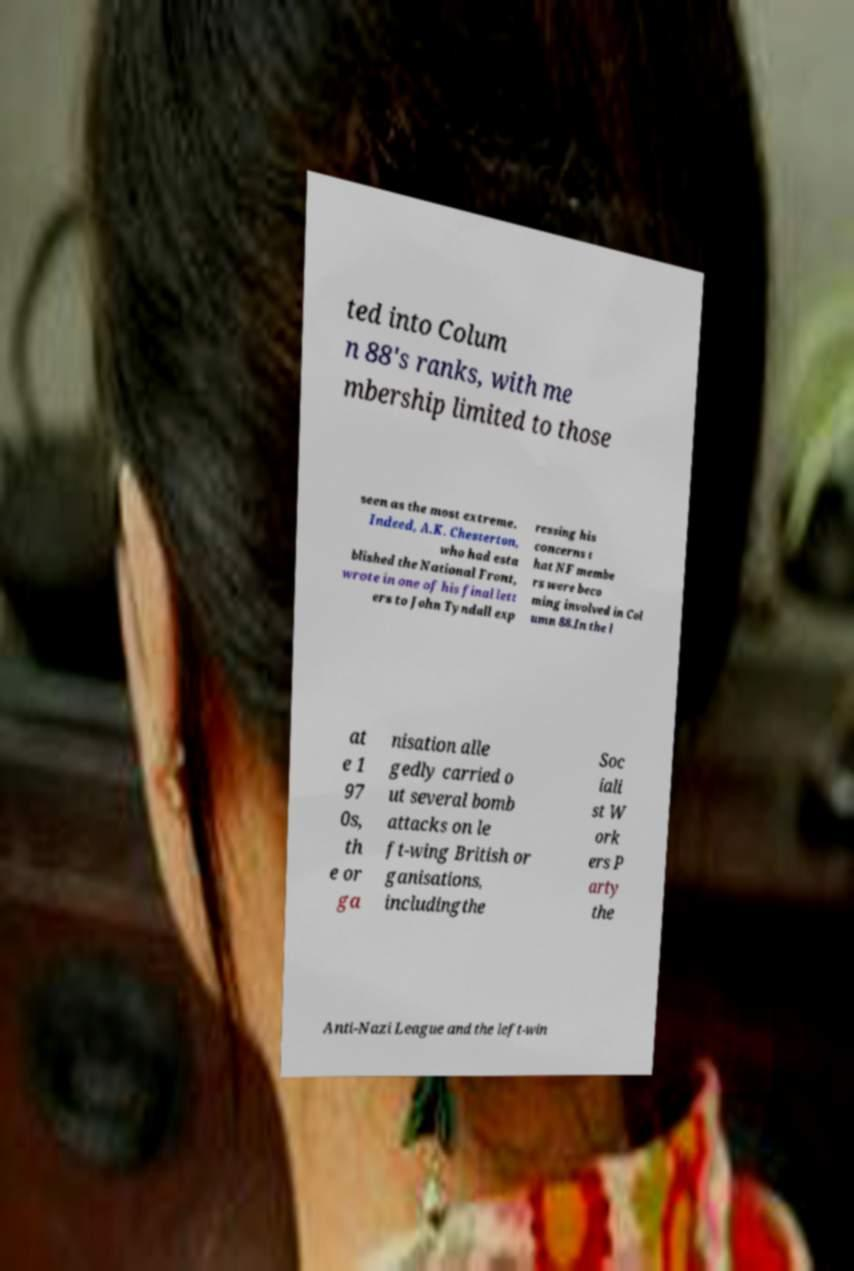Please read and relay the text visible in this image. What does it say? ted into Colum n 88's ranks, with me mbership limited to those seen as the most extreme. Indeed, A.K. Chesterton, who had esta blished the National Front, wrote in one of his final lett ers to John Tyndall exp ressing his concerns t hat NF membe rs were beco ming involved in Col umn 88.In the l at e 1 97 0s, th e or ga nisation alle gedly carried o ut several bomb attacks on le ft-wing British or ganisations, includingthe Soc iali st W ork ers P arty the Anti-Nazi League and the left-win 